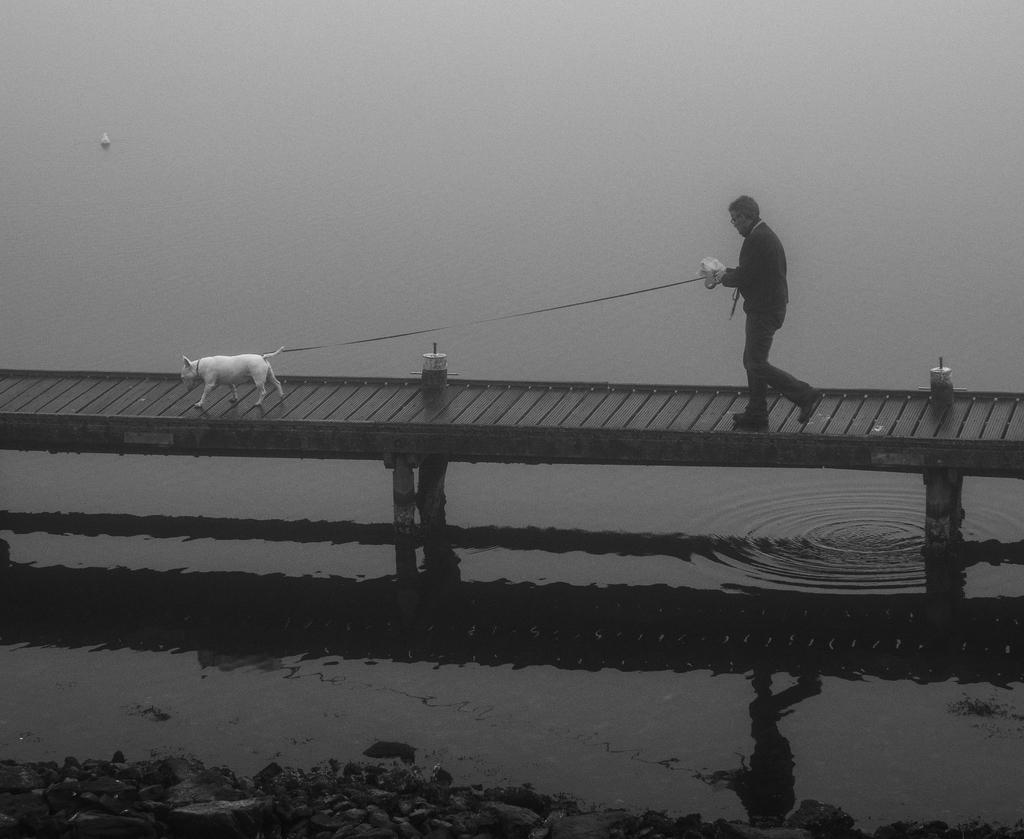What type of animal is in the image? There is a dog in the image. Who or what else is in the image? There is a person in the image. What are the person and dog doing in the image? The person and dog are walking on a wooden path. What can be seen in the background of the image? There is water visible in the image, and there are rocks present. What type of horn can be seen on the dog's head in the image? There is no horn present on the dog's head in the image. Is there a girl in the image? The provided facts do not mention a girl in the image, only a person. 